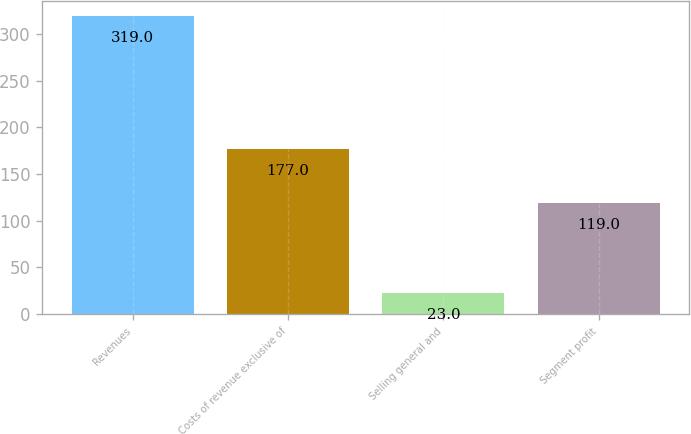<chart> <loc_0><loc_0><loc_500><loc_500><bar_chart><fcel>Revenues<fcel>Costs of revenue exclusive of<fcel>Selling general and<fcel>Segment profit<nl><fcel>319<fcel>177<fcel>23<fcel>119<nl></chart> 